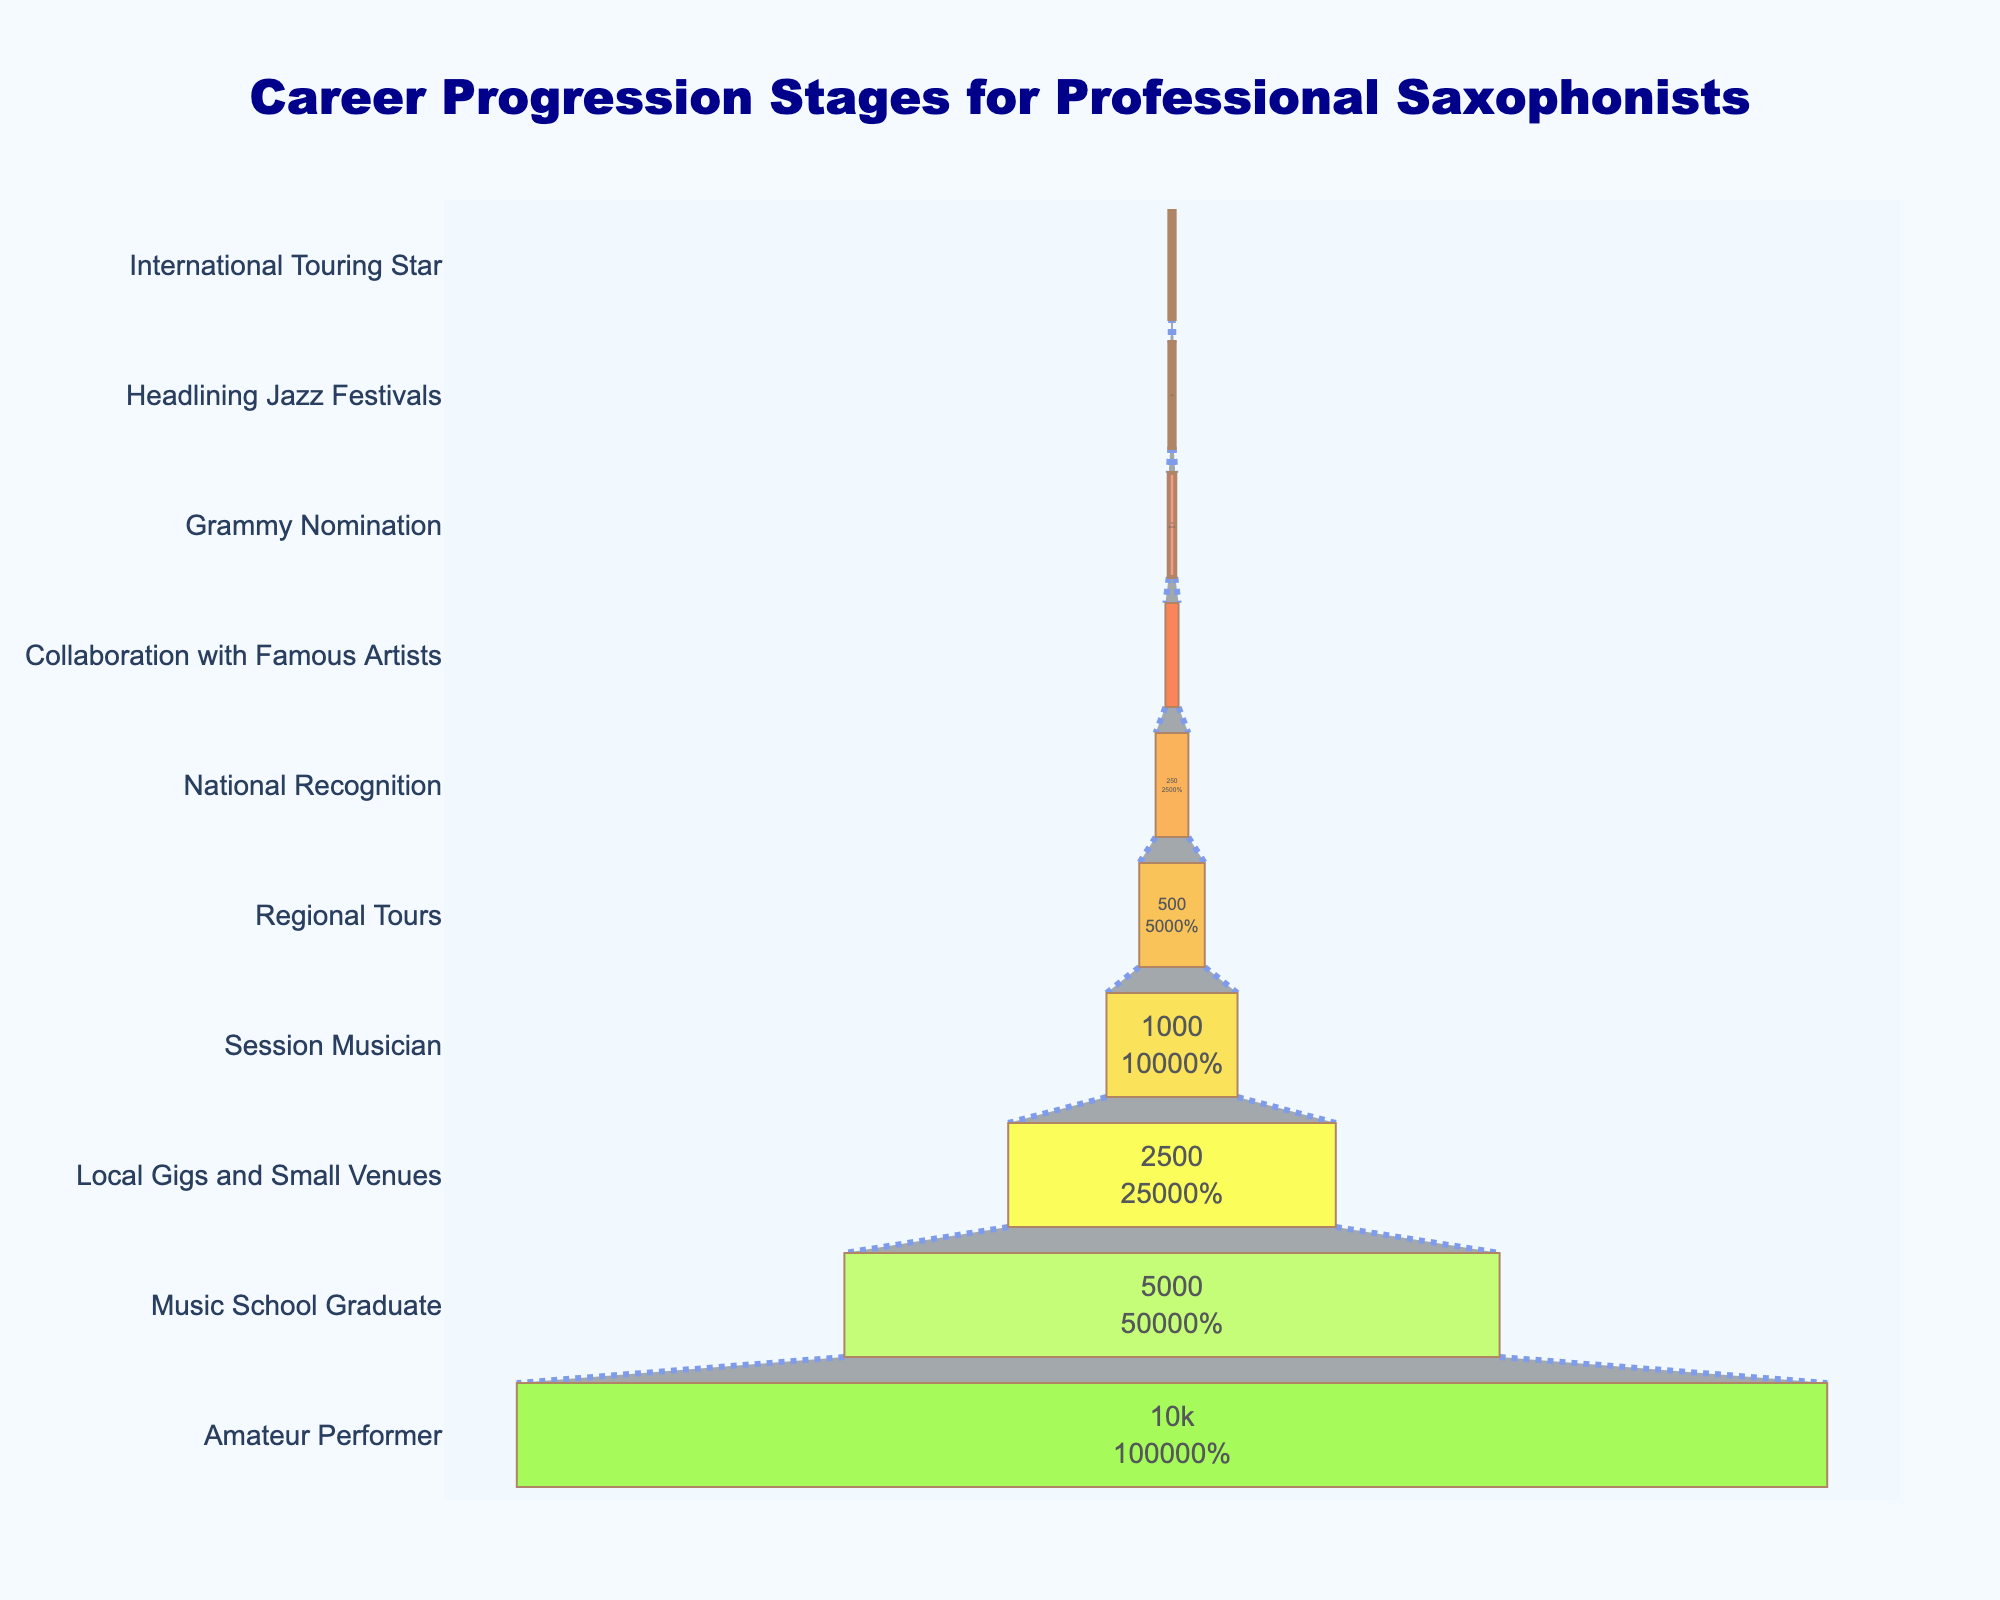what is the title of the chart? The title of the chart is displayed at the top center. It reads "Career Progression Stages for Professional Saxophonists".
Answer: Career Progression Stages for Professional Saxophonists How many saxophonists are at the "Music School Graduate" stage? Look at the "Music School Graduate" stage on the y-axis, then read the corresponding number on the x-axis, which is 5000.
Answer: 5000 How many stages are represented in the funnel chart? Count the number of stages listed on the y-axis. There are 10 stages in total.
Answer: 10 Which stage has the fewest saxophonists? Identify the stage with the smallest number on the x-axis. The "International Touring Star" stage has 10 saxophonists.
Answer: International Touring Star How many more saxophonists are in the "Amateur Performer" stage compared to the "Session Musician" stage? The "Amateur Performer" stage has 10000 saxophonists, and the "Session Musician" stage has 1000 saxophonists. The difference is 10000 - 1000 = 9000.
Answer: 9000 What percentage of saxophonists have reached the "National Recognition" stage compared to the number at the "Amateur Performer" stage? The "National Recognition" stage has 250 saxophonists, and the "Amateur Performer" stage has 10000. The percentage is (250/10000)*100 = 2.5%.
Answer: 2.5% Which stage comes immediately before "Grammy Nomination"? Look at the y-axis to see the stage listed immediately before "Grammy Nomination". It is "Collaboration with Famous Artists".
Answer: Collaboration with Famous Artists Are there more saxophonists at the "Regional Tours" stage or the "Grammy Nomination" stage? Compare the numbers for "Regional Tours" (500) and "Grammy Nomination" (50). 500 > 50, so there are more saxophonists at the "Regional Tours" stage.
Answer: Regional Tours What is the combined number of saxophonists at the "Headlining Jazz Festivals" and "International Touring Star" stages? Add the number of saxophonists at the "Headlining Jazz Festivals" stage (25) to those at the "International Touring Star" stage (10). The total is 25 + 10 = 35.
Answer: 35 